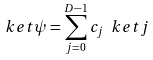<formula> <loc_0><loc_0><loc_500><loc_500>\ k e t { \psi } = \sum _ { j = 0 } ^ { D - 1 } c _ { j } \ k e t { j }</formula> 